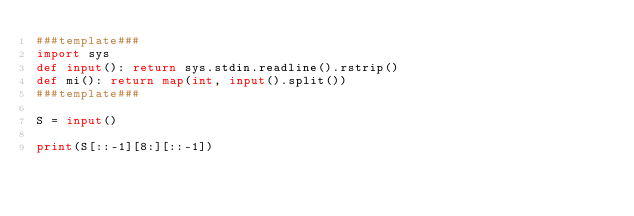<code> <loc_0><loc_0><loc_500><loc_500><_Python_>###template###
import sys
def input(): return sys.stdin.readline().rstrip()
def mi(): return map(int, input().split())
###template###

S = input()

print(S[::-1][8:][::-1])

</code> 